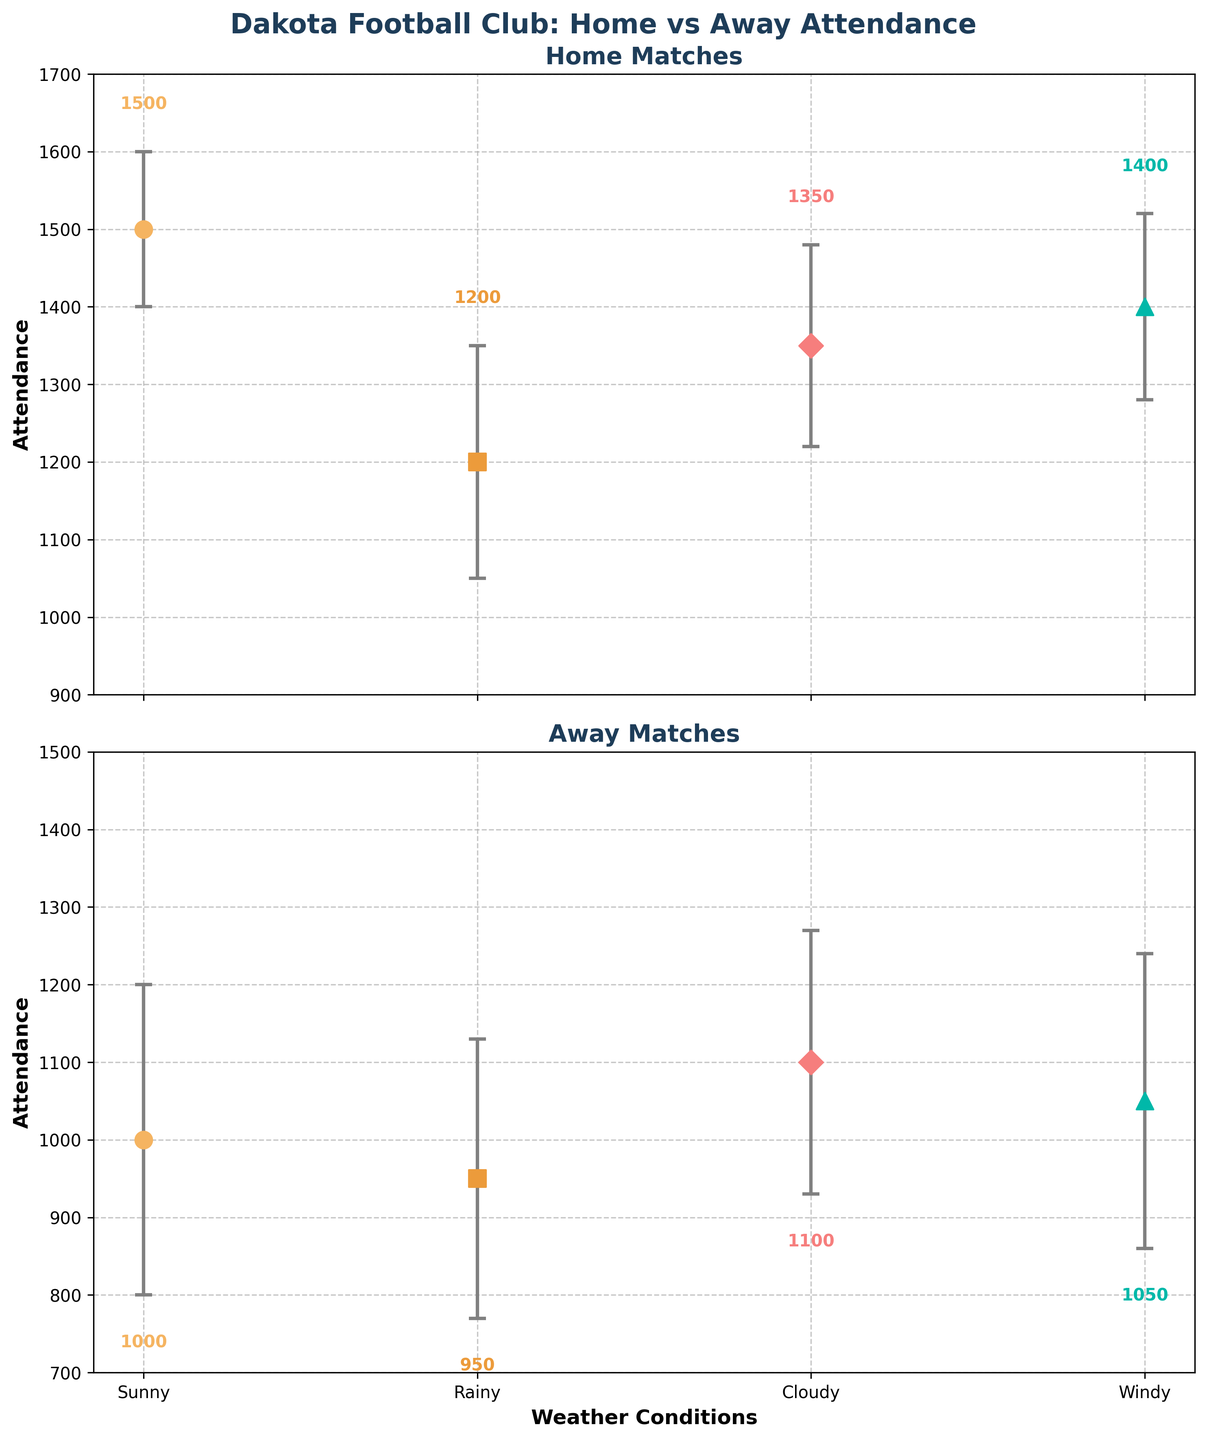What is the attendance for home matches on sunny days? The plot shows that home matches on sunny days have an attendance marked at 1500.
Answer: 1500 How does the attendance compare between home and away matches on windy days? The attendance for home matches on windy days is 1400, while for away matches, it is 1050.
Answer: Home: 1400, Away: 1050 Which weather condition sees the highest attendance for home matches? By comparing the attendance values for all the weather conditions in home matches, the highest is during sunny days with 1500.
Answer: Sunny Which weather condition has the highest standard error for away matches? The plot indicates standard errors through error bars, and the longest bar corresponds to cloudy days with a standard error of 170.
Answer: Cloudy What is the average attendance for away matches across all weather conditions? Adding the attendance for all types of weather for away matches (1000 + 950 + 1100 + 1050) gives 4100. Dividing by the number of weather conditions (4) results in an average of 1025.
Answer: 1025 What is the difference in attendance between home and away matches on rainy days? The attendance on rainy days for home matches is 1200 and for away matches is 950. The difference is 1200 - 950 = 250.
Answer: 250 Which weather condition shows the smallest difference in attendance between home and away matches? Subtracting away match attendance from home match attendance for each weather condition: Sunny (500), Rainy (250), Cloudy (250), Windy (350). The smallest difference is 250 (Rainy and Cloudy).
Answer: Rainy and Cloudy What is the range of attendance for home matches across different weather conditions? The highest attendance for home matches is 1500 (Sunny), and the lowest is 1200 (Rainy). The range is 1500 - 1200 = 300.
Answer: 300 How does the variability of attendance in home matches compare to away matches? By observing the error bars in the plot, home matches generally have shorter error bars compared to away matches, indicating lower variability.
Answer: Home matches have lower variability What can be inferred about the correlation between weather conditions and match attendance for home games? The attendance is highest on sunny days and decreases in less favorable weather conditions. This suggests that more favorable weather generally attracts higher attendance for home games.
Answer: Favorable weather increases attendance 